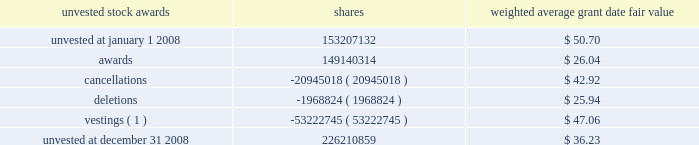Employees .
As explained below , pursuant to sfas 123 ( r ) , the charge to income for awards made to retirement-eligible employees is accelerated based on the dates the retirement rules are met .
Cap and certain other awards provide that participants who meet certain age and years of service conditions may continue to vest in all or a portion of the award without remaining employed by the company during the entire vesting period , so long as they do not compete with citigroup during that time .
Beginning in 2006 , awards to these retirement-eligible employees are recognized in the year prior to the grant in the same manner as cash incentive compensation is accrued .
However , awards granted in january 2006 were required to be expensed in their entirety at the date of grant .
Prior to 2006 , all awards were recognized ratably over the stated vesting period .
See note 1 to the consolidated financial statements on page 122 for the impact of adopting sfas 123 ( r ) .
From 2003 to 2007 , citigroup granted restricted or deferred shares annually under the citigroup ownership program ( cop ) to eligible employees .
This program replaced the wealthbuilder , citibuilder and citigroup ownership stock option programs .
Under cop , eligible employees received either restricted or deferred shares of citigroup common stock that vest after three years .
The last award under this program was in 2007 .
Unearned compensation expense associated with the stock grants represents the market value of citigroup common stock at the date of grant and is recognized as a charge to income ratably over the vesting period , except for those awards granted to retirement-eligible employees .
The charge to income for awards made to retirement-eligible employees is accelerated based on the dates the retirement rules are met .
On july 17 , 2007 , the personnel and compensation committee of citigroup 2019s board of directors approved the management committee long- term incentive plan ( mc ltip ) , under the terms of the shareholder- approved 1999 stock incentive plan .
The mc ltip provides members of the citigroup management committee , including the ceo , cfo and the named executive officers in the citigroup proxy statement , an opportunity to earn stock awards based on citigroup 2019s performance .
Each participant received an equity award that will be earned based on citigroup 2019s performance for the period from july 1 , 2007 to december 31 , 2009 .
Three periods will be measured for performance ( july 1 , 2007 to december 31 , 2007 , full year 2008 and full year 2009 ) .
The ultimate value of the award will be based on citigroup 2019s performance in each of these periods with respect to ( 1 ) total shareholder return versus citigroup 2019s current key competitors and ( 2 ) publicly stated return on equity ( roe ) targets measured at the end of each calendar year .
If , in any of the three performance periods , citigroup 2019s total shareholder return does not exceed the median performance of the peer group , the participants will not receive award shares for that period .
The awards will generally vest after 30 months .
In order to receive the shares , a participant generally must be a citigroup employee on january 5 , 2010 .
The final expense for each of the three calendar years will be adjusted based on the results of the roe tests .
No awards were earned for 2008 or 2007 because performance targets were not met .
No new awards were made under the mc ltip since the initial award in july 2007 .
On january 22 , 2008 , special retention stock awards were made to key senior executive officers and certain other members of senior management .
The awards vest ratably over two- or four-year periods .
Executives must remain employed through the vesting dates to receive the shares awarded , except in cases of death , disability , or involuntary termination other than for gross misconduct .
Unlike cap , post-employment vesting is not provided for participants who meet specified age and years of service conditions .
Shares subject to some of the awards are exempted from the stock ownership commitment .
A summary of the status of citigroup 2019s unvested stock awards as of december 31 , 2008 , and changes during the 12 months ended december 31 , 2008 , is presented below : unvested stock awards shares weighted average grant date fair value .
( 1 ) the weighted average market value of the vestings during 2008 was approximately $ 22.31 per share .
As of december 31 , 2008 , there was $ 3.3 billion of total unrecognized compensation cost related to unvested stock awards net of the forfeiture provision .
That cost is expected to be recognized over a weighted-average period of 2.6 years. .
As of 2008 what was annual cost is expected to be recognized of the total unrecognized compensation cost related to unvested stock awards net of the forfeiture provision in billions\\n? 
Computations: (3.3 / 2.6)
Answer: 1.26923. 